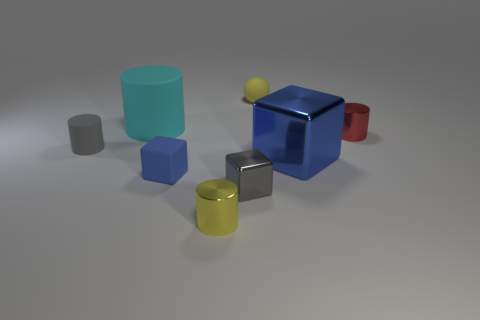Subtract all small matte cylinders. How many cylinders are left? 3 Add 1 red matte objects. How many objects exist? 9 Subtract all blue cubes. How many cubes are left? 1 Subtract 1 cubes. How many cubes are left? 2 Subtract all yellow spheres. How many blue cubes are left? 2 Subtract all balls. How many objects are left? 7 Add 4 tiny yellow cylinders. How many tiny yellow cylinders are left? 5 Add 1 big matte objects. How many big matte objects exist? 2 Subtract 0 cyan cubes. How many objects are left? 8 Subtract all cyan cylinders. Subtract all yellow spheres. How many cylinders are left? 3 